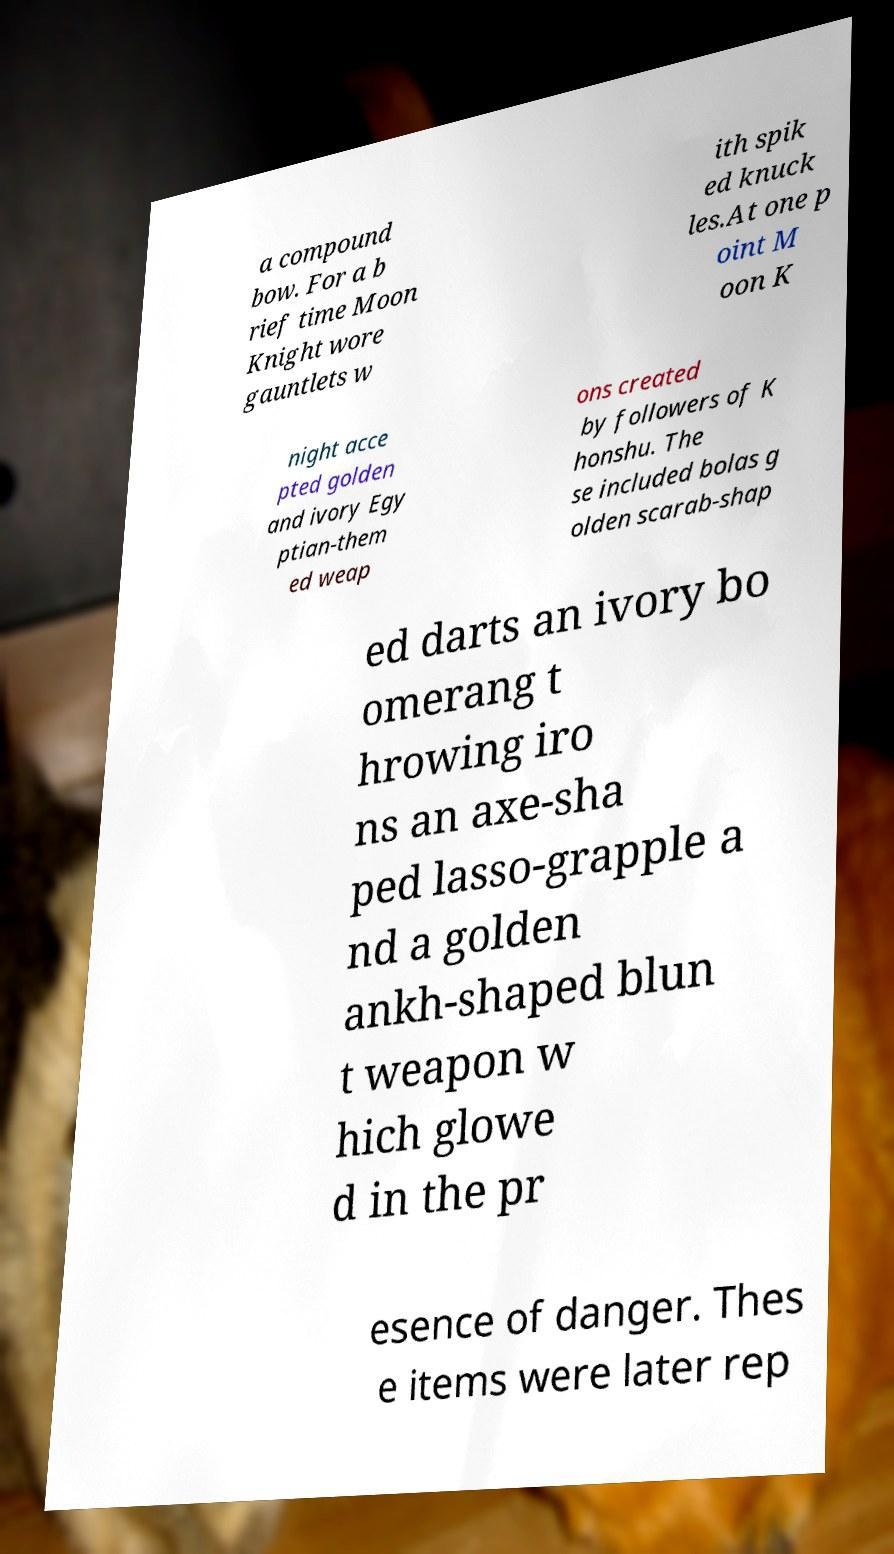Please identify and transcribe the text found in this image. a compound bow. For a b rief time Moon Knight wore gauntlets w ith spik ed knuck les.At one p oint M oon K night acce pted golden and ivory Egy ptian-them ed weap ons created by followers of K honshu. The se included bolas g olden scarab-shap ed darts an ivory bo omerang t hrowing iro ns an axe-sha ped lasso-grapple a nd a golden ankh-shaped blun t weapon w hich glowe d in the pr esence of danger. Thes e items were later rep 